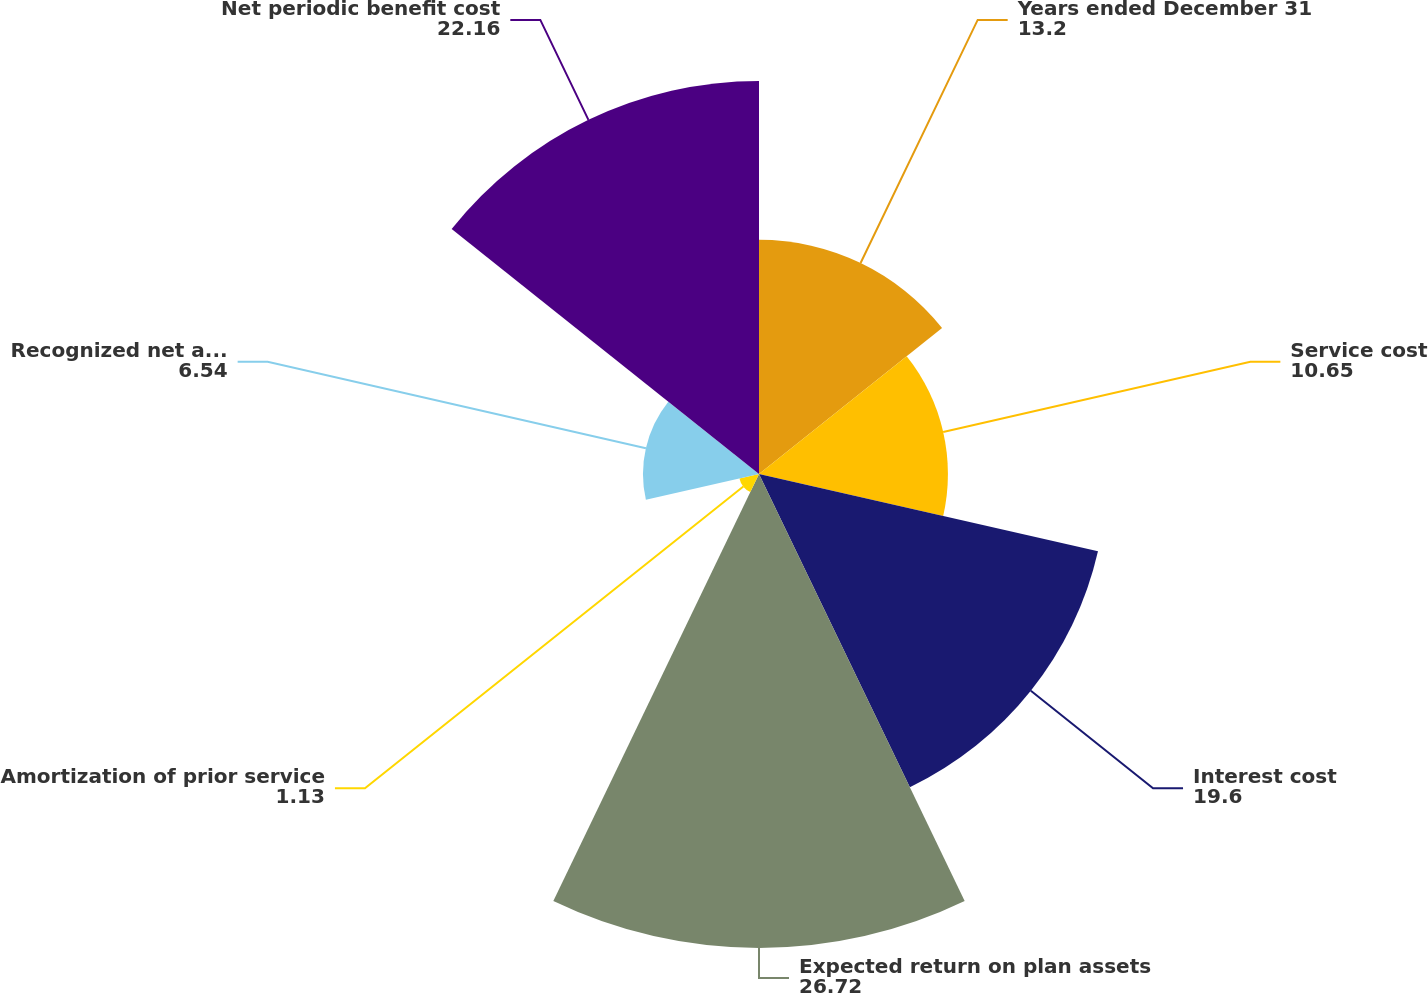<chart> <loc_0><loc_0><loc_500><loc_500><pie_chart><fcel>Years ended December 31<fcel>Service cost<fcel>Interest cost<fcel>Expected return on plan assets<fcel>Amortization of prior service<fcel>Recognized net actuarial loss<fcel>Net periodic benefit cost<nl><fcel>13.2%<fcel>10.65%<fcel>19.6%<fcel>26.72%<fcel>1.13%<fcel>6.54%<fcel>22.16%<nl></chart> 